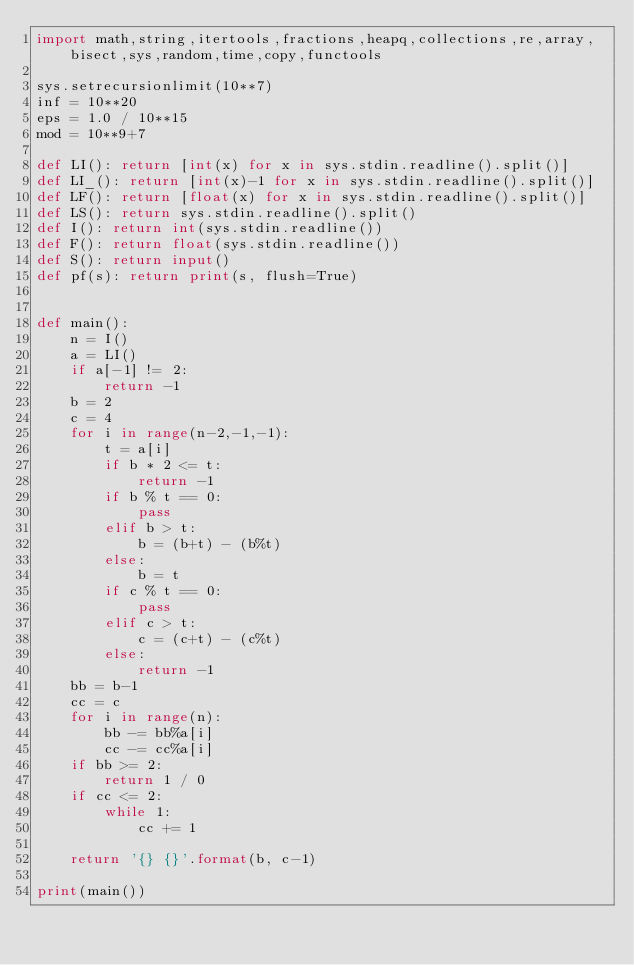<code> <loc_0><loc_0><loc_500><loc_500><_Python_>import math,string,itertools,fractions,heapq,collections,re,array,bisect,sys,random,time,copy,functools

sys.setrecursionlimit(10**7)
inf = 10**20
eps = 1.0 / 10**15
mod = 10**9+7

def LI(): return [int(x) for x in sys.stdin.readline().split()]
def LI_(): return [int(x)-1 for x in sys.stdin.readline().split()]
def LF(): return [float(x) for x in sys.stdin.readline().split()]
def LS(): return sys.stdin.readline().split()
def I(): return int(sys.stdin.readline())
def F(): return float(sys.stdin.readline())
def S(): return input()
def pf(s): return print(s, flush=True)


def main():
    n = I()
    a = LI()
    if a[-1] != 2:
        return -1
    b = 2
    c = 4
    for i in range(n-2,-1,-1):
        t = a[i]
        if b * 2 <= t:
            return -1
        if b % t == 0:
            pass
        elif b > t:
            b = (b+t) - (b%t)
        else:
            b = t
        if c % t == 0:
            pass
        elif c > t:
            c = (c+t) - (c%t)
        else:
            return -1
    bb = b-1
    cc = c
    for i in range(n):
        bb -= bb%a[i]
        cc -= cc%a[i]
    if bb >= 2:
        return 1 / 0
    if cc <= 2:
        while 1:
            cc += 1

    return '{} {}'.format(b, c-1)

print(main())


</code> 